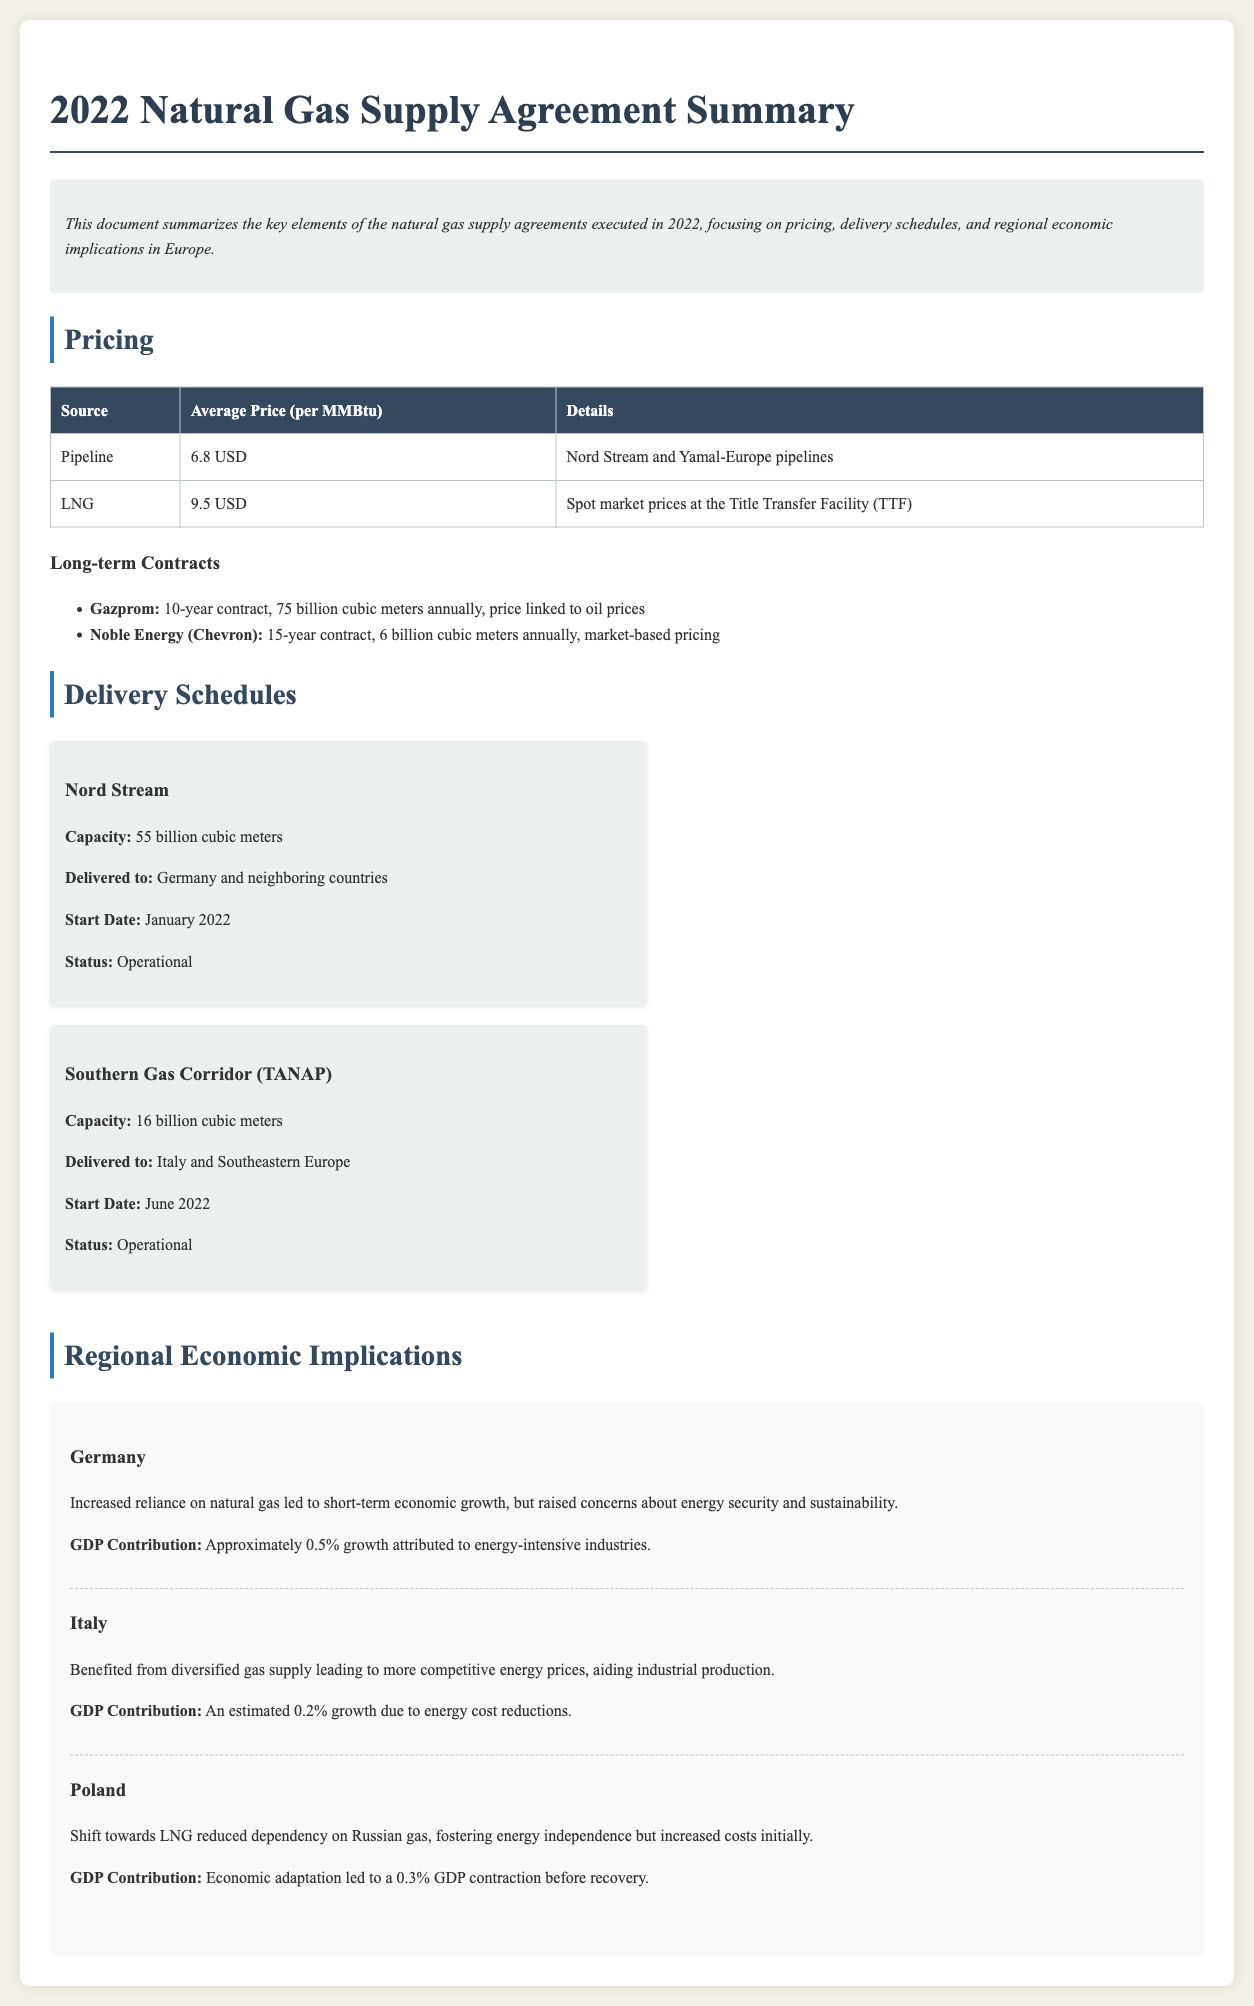What is the average price of natural gas from pipelines? The average price of natural gas from pipelines is stated directly in the pricing section of the document.
Answer: 6.8 USD What is the capacity of the Southern Gas Corridor (TANAP)? The capacity of the Southern Gas Corridor is detailed in the delivery schedules section of the document.
Answer: 16 billion cubic meters What percentage of GDP growth in Germany is attributed to energy-intensive industries? The document provides this specific information under the regional economic implications section for Germany.
Answer: Approximately 0.5% Which company has a 10-year contract for 75 billion cubic meters annually? This detail is mentioned in the long-term contracts section of the document.
Answer: Gazprom What was the start date for the Nord Stream delivery route? The start date for the Nord Stream is mentioned in the delivery schedules section of the document.
Answer: January 2022 How did Poland's shift toward LNG initially affect its GDP? The document discusses the economic implications for Poland, including the impact on GDP.
Answer: 0.3% contraction What kind of pricing does Noble Energy's contract utilize? The type of pricing for Noble Energy's contract is specified in the long-term contracts section of the document.
Answer: Market-based pricing What economic benefit did Italy gain from a diversified gas supply? The economic benefits for Italy are outlined in the regional economic implications section of the document.
Answer: Competitive energy prices What is the status of the Southern Gas Corridor (TANAP)? The operational status of the Southern Gas Corridor is described in the delivery schedules section.
Answer: Operational 